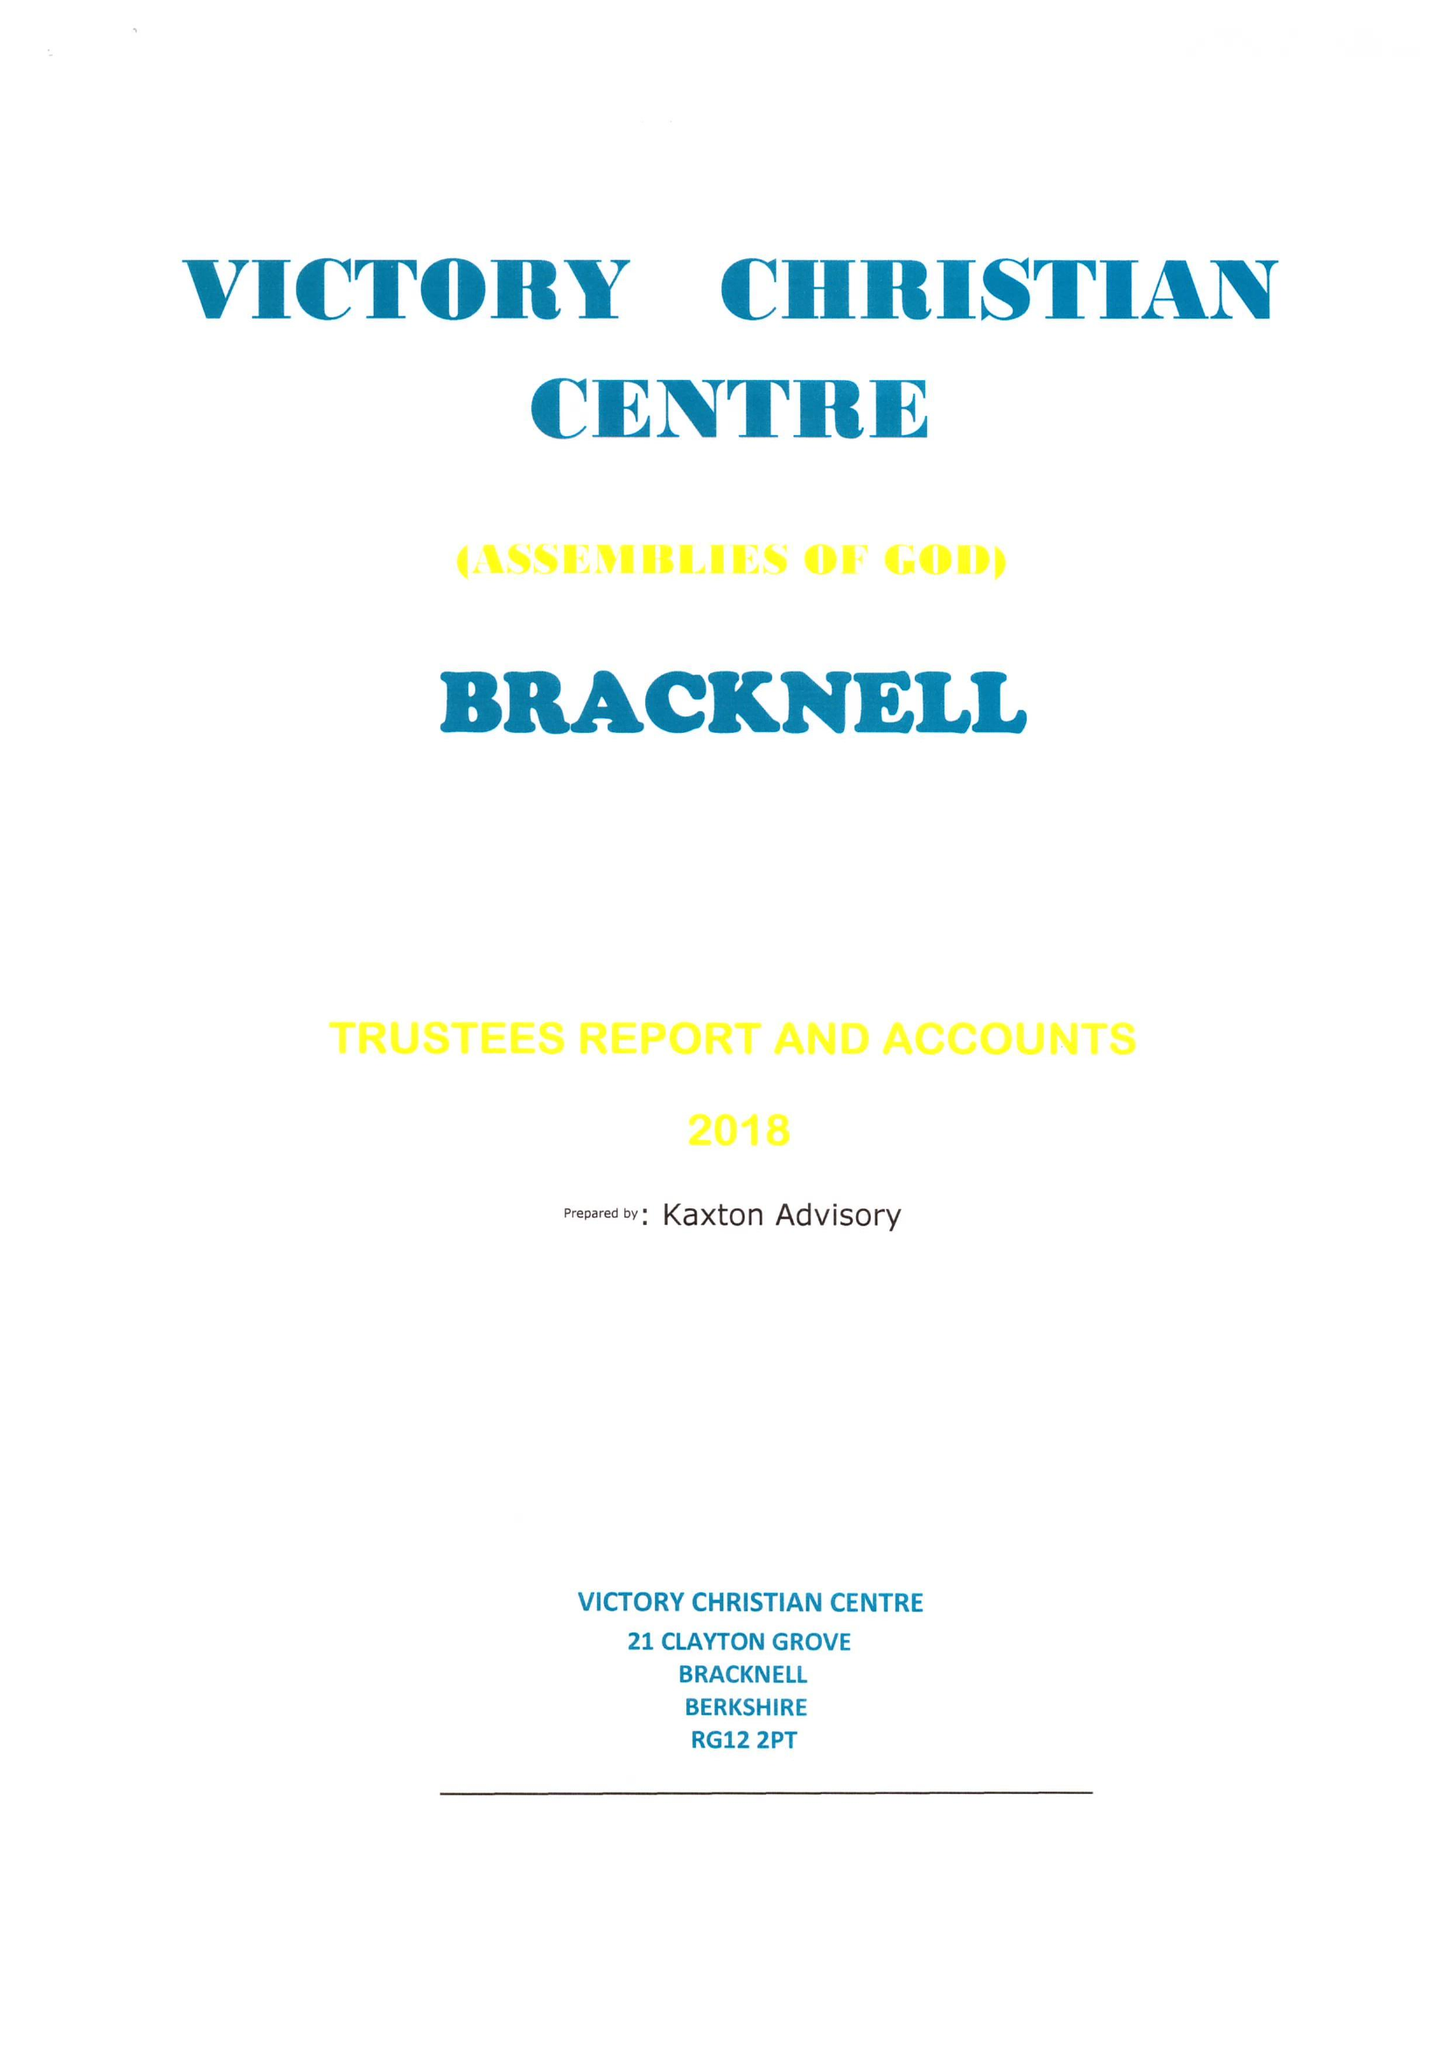What is the value for the charity_number?
Answer the question using a single word or phrase. 1170120 